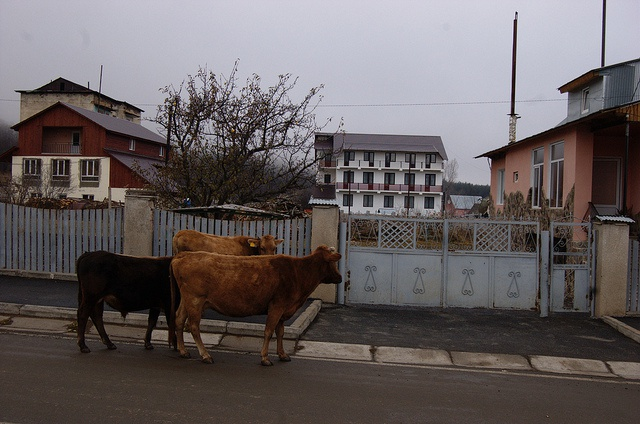Describe the objects in this image and their specific colors. I can see cow in darkgray, black, maroon, and brown tones, cow in darkgray, black, gray, and maroon tones, and cow in darkgray, maroon, black, and brown tones in this image. 